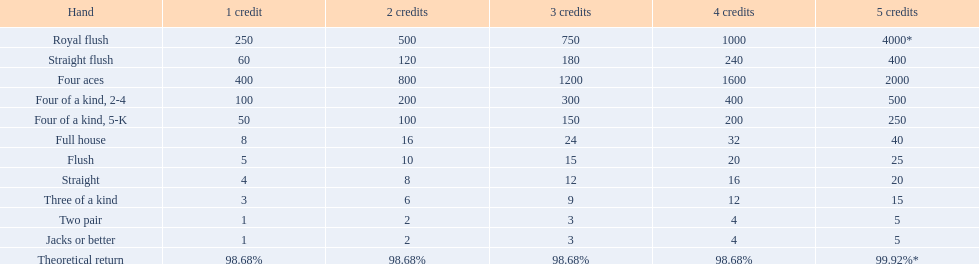What are the various hands? Royal flush, Straight flush, Four aces, Four of a kind, 2-4, Four of a kind, 5-K, Full house, Flush, Straight, Three of a kind, Two pair, Jacks or better. Which hands hold a greater rank than a straight? Royal flush, Straight flush, Four aces, Four of a kind, 2-4, Four of a kind, 5-K, Full house, Flush. Among these, which hand is the next highest following a straight? Flush. 